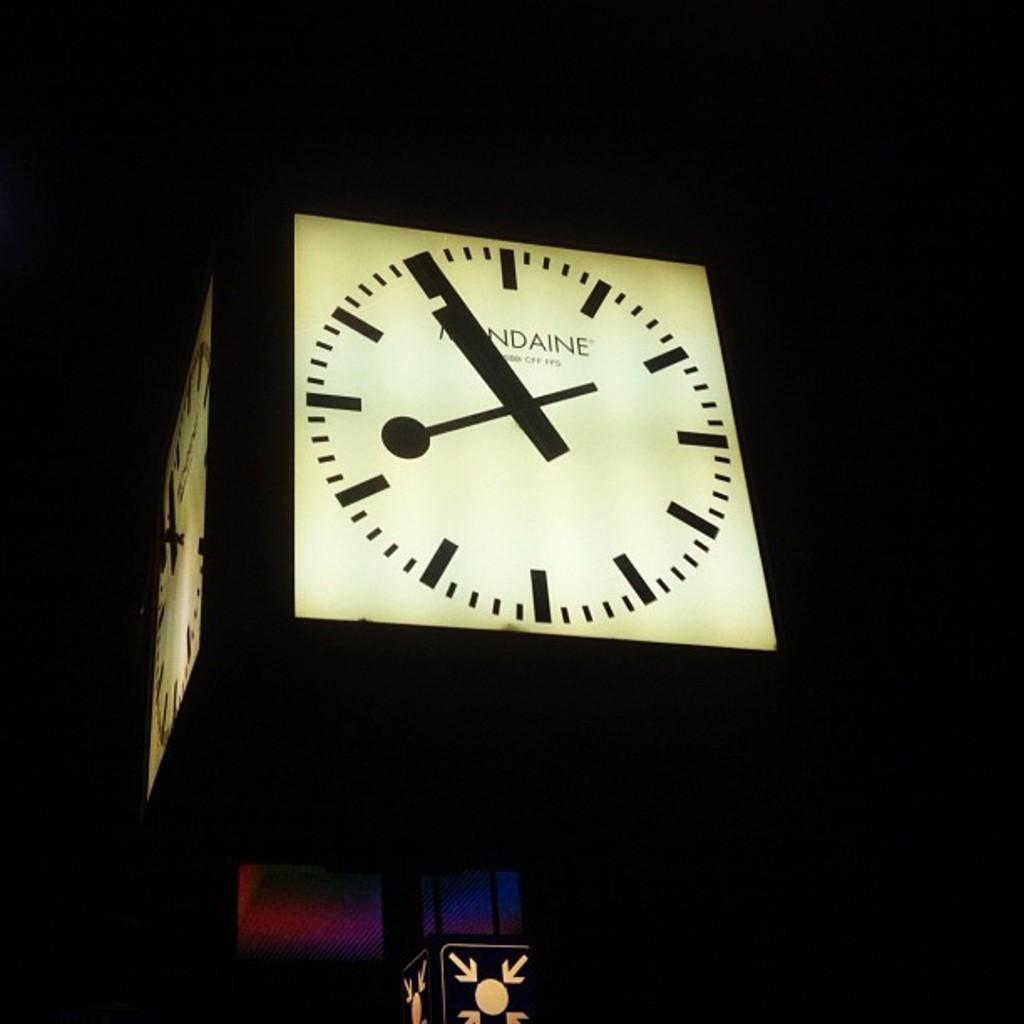Provide a one-sentence caption for the provided image. A lit-up clock face has a word that ends with "ndaine" on the face. 